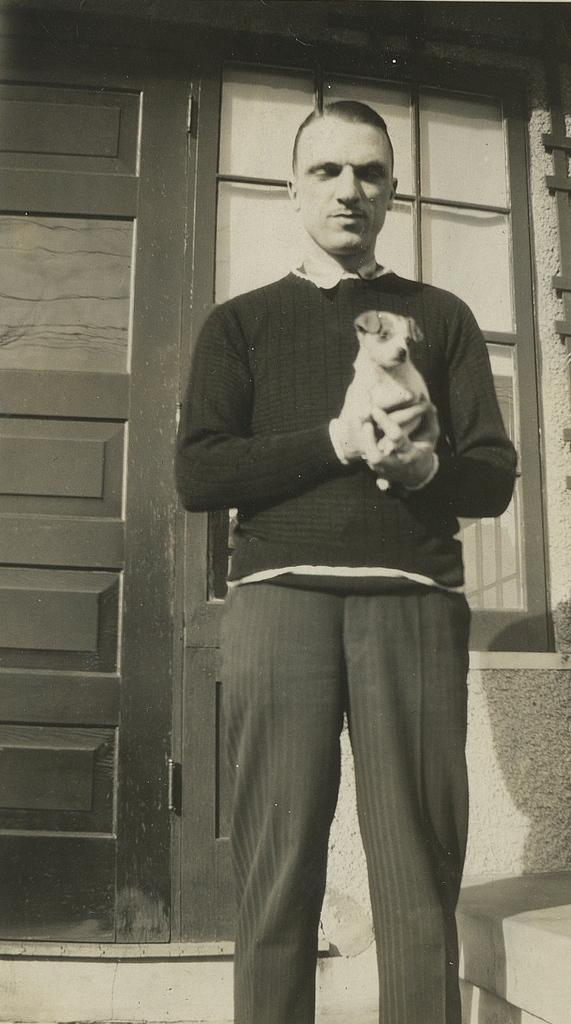What is the main subject of the image? The main subject of the image is a man. What is the man doing in the image? The man is holding a dog in his hands. What type of airplane is the man flying in the image? There is no airplane present in the image; the man is holding a dog in his hands. How does the ice help the man hold the dog in the image? There is no ice present in the image, and it is not involved in the man holding the dog. 